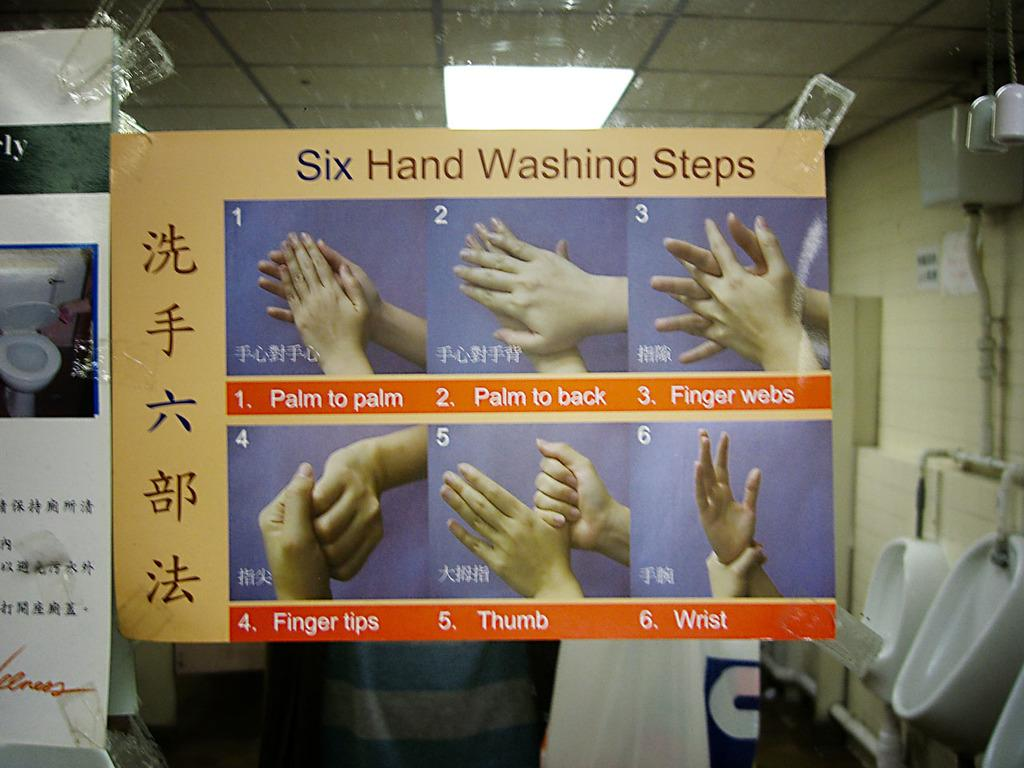<image>
Provide a brief description of the given image. A placard with the six steps for washing ones hands. 